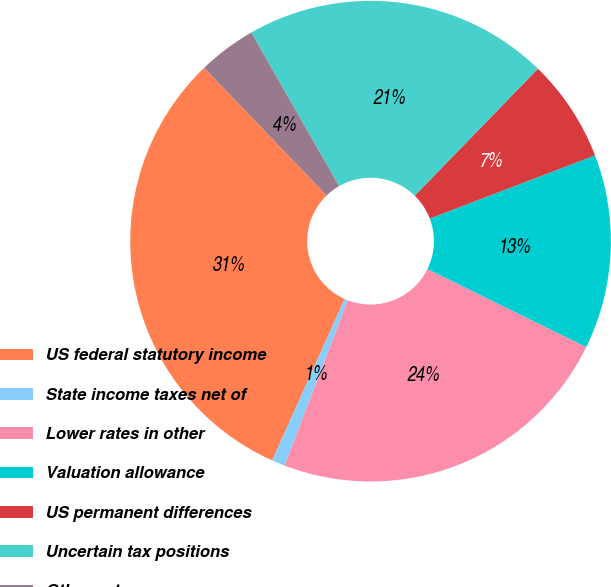Convert chart to OTSL. <chart><loc_0><loc_0><loc_500><loc_500><pie_chart><fcel>US federal statutory income<fcel>State income taxes net of<fcel>Lower rates in other<fcel>Valuation allowance<fcel>US permanent differences<fcel>Uncertain tax positions<fcel>Other net<nl><fcel>31.11%<fcel>0.89%<fcel>23.56%<fcel>13.07%<fcel>6.93%<fcel>20.53%<fcel>3.91%<nl></chart> 